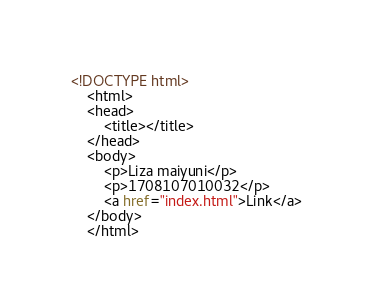<code> <loc_0><loc_0><loc_500><loc_500><_HTML_><!DOCTYPE html>
	<html>
	<head>
		<title></title>
	</head>
	<body>
		<p>Liza maiyuni</p>
		<p>1708107010032</p>
		<a href="index.html">Link</a>
	</body>
	</html></code> 